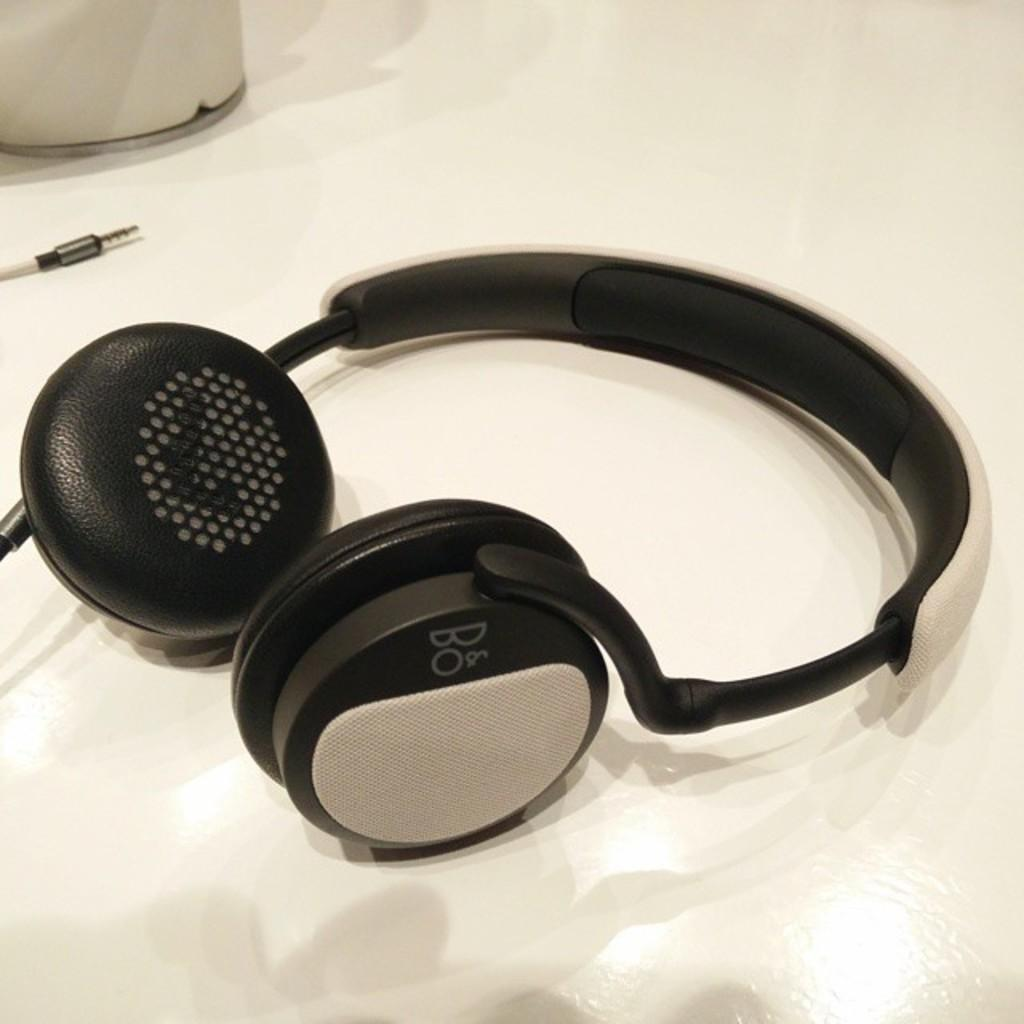What type of audio device is present in the image? There is a headphone in the image. What colors are used for the headphone? The headphone is white and black in color. Is there any connection between the headphone and another object in the image? Yes, there is a wire associated with the headphone. What other white object can be seen in the image? There is a white object in the image. On what surface are the headphone and the white object placed? Both the headphone and the white object are on a white surface. What type of building is visible in the image? There is no building present in the image; it only features a headphone, a white object, and a white surface. What type of growth can be seen on the headphone in the image? There is no growth visible on the headphone in the image. 